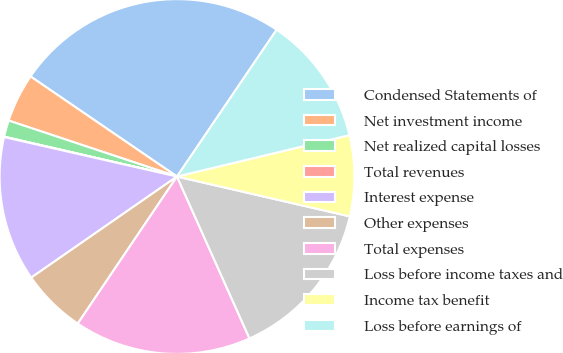Convert chart. <chart><loc_0><loc_0><loc_500><loc_500><pie_chart><fcel>Condensed Statements of<fcel>Net investment income<fcel>Net realized capital losses<fcel>Total revenues<fcel>Interest expense<fcel>Other expenses<fcel>Total expenses<fcel>Loss before income taxes and<fcel>Income tax benefit<fcel>Loss before earnings of<nl><fcel>24.95%<fcel>4.43%<fcel>1.5%<fcel>0.04%<fcel>13.22%<fcel>5.9%<fcel>16.15%<fcel>14.69%<fcel>7.36%<fcel>11.76%<nl></chart> 